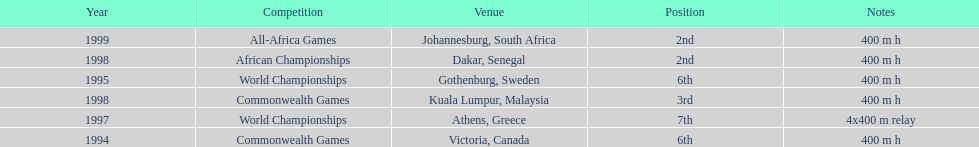Other than 1999, what year did ken harnden win second place? 1998. Would you be able to parse every entry in this table? {'header': ['Year', 'Competition', 'Venue', 'Position', 'Notes'], 'rows': [['1999', 'All-Africa Games', 'Johannesburg, South Africa', '2nd', '400 m h'], ['1998', 'African Championships', 'Dakar, Senegal', '2nd', '400 m h'], ['1995', 'World Championships', 'Gothenburg, Sweden', '6th', '400 m h'], ['1998', 'Commonwealth Games', 'Kuala Lumpur, Malaysia', '3rd', '400 m h'], ['1997', 'World Championships', 'Athens, Greece', '7th', '4x400 m relay'], ['1994', 'Commonwealth Games', 'Victoria, Canada', '6th', '400 m h']]} 